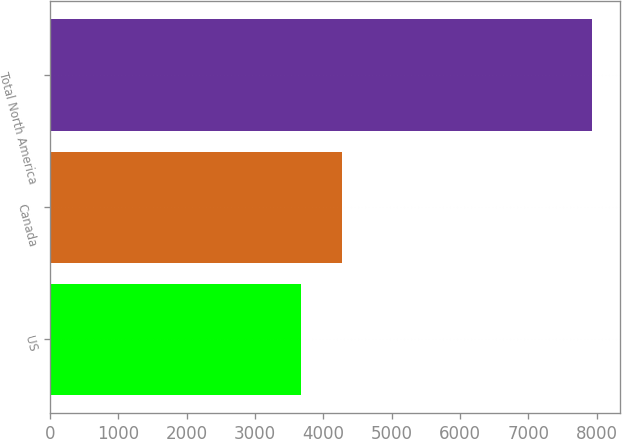Convert chart. <chart><loc_0><loc_0><loc_500><loc_500><bar_chart><fcel>US<fcel>Canada<fcel>Total North America<nl><fcel>3669<fcel>4271<fcel>7940<nl></chart> 